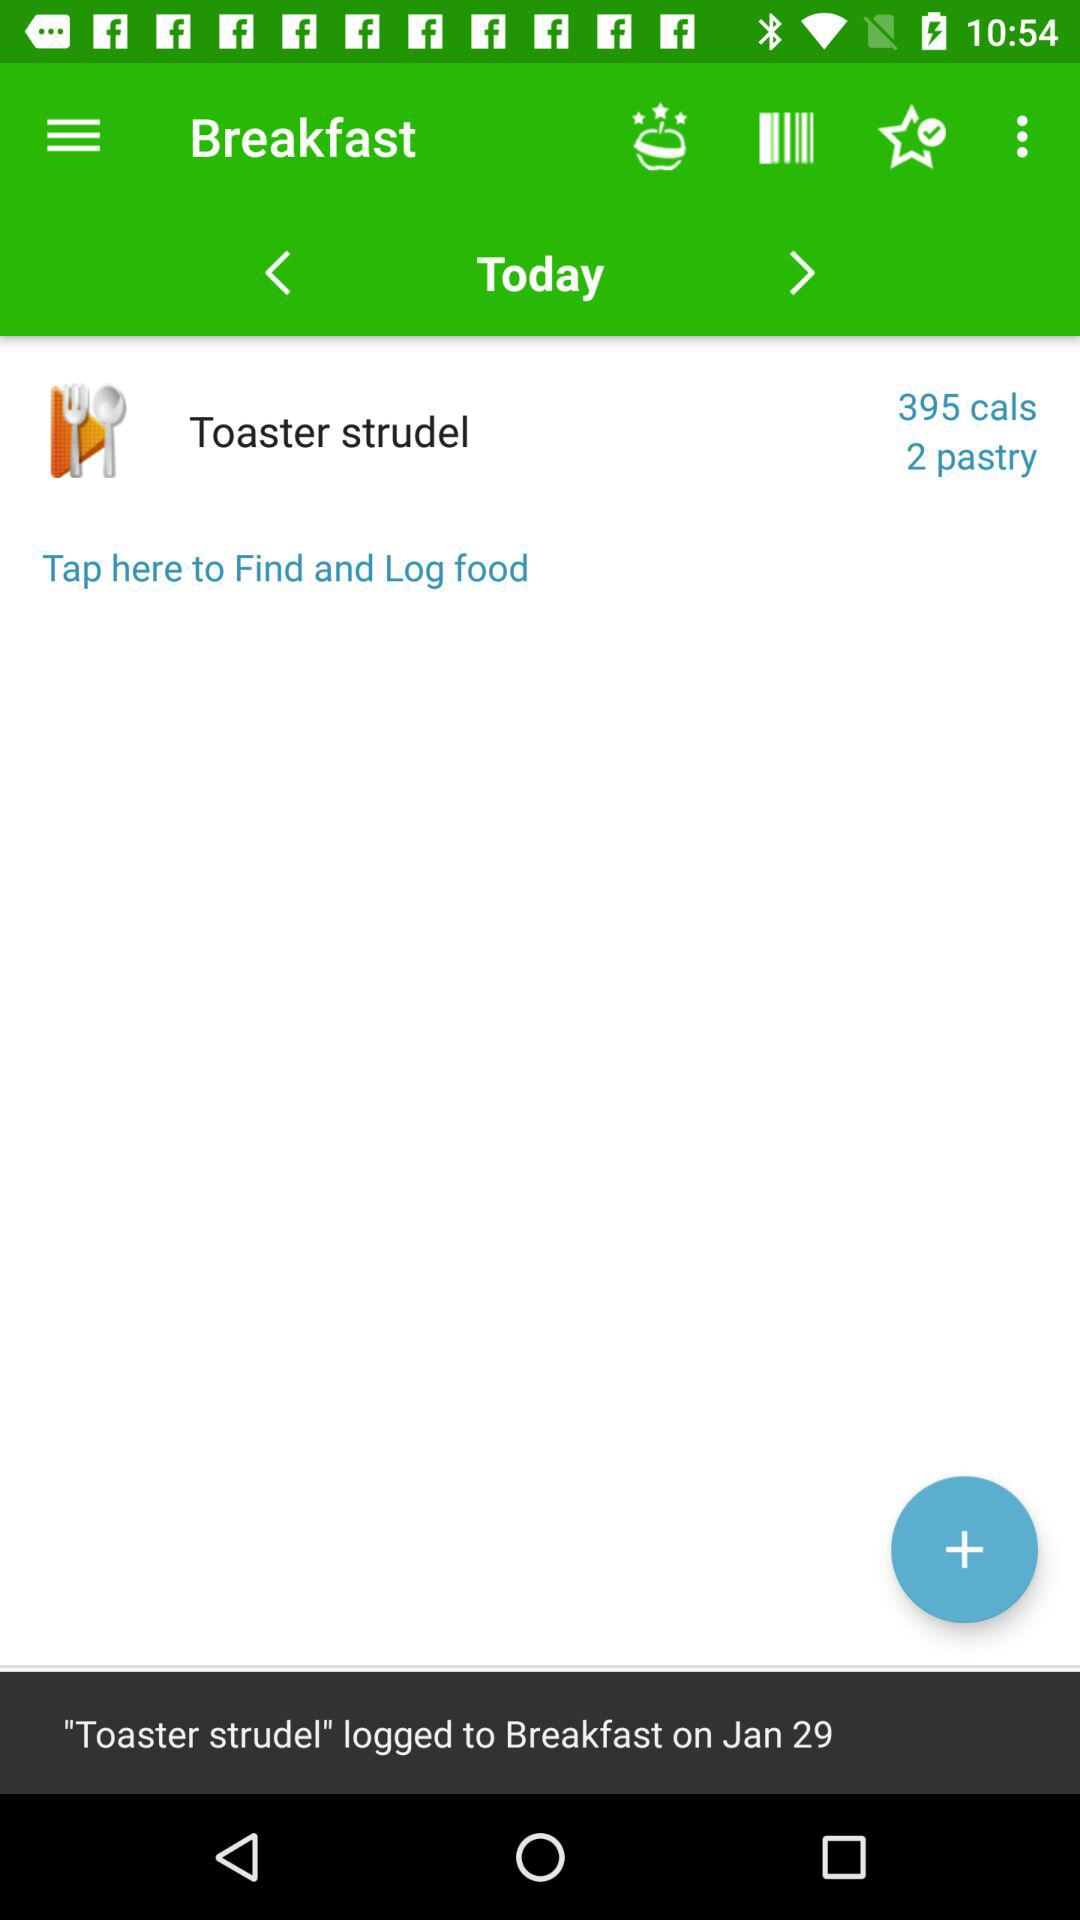How many calories are in the toaster strudel?
Answer the question using a single word or phrase. 395 